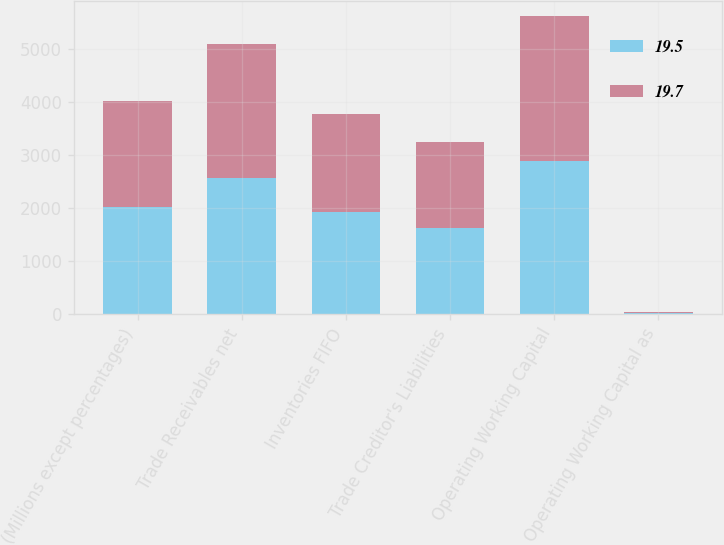<chart> <loc_0><loc_0><loc_500><loc_500><stacked_bar_chart><ecel><fcel>(Millions except percentages)<fcel>Trade Receivables net<fcel>Inventories FIFO<fcel>Trade Creditor's Liabilities<fcel>Operating Working Capital<fcel>Operating Working Capital as<nl><fcel>19.5<fcel>2012<fcel>2568<fcel>1930<fcel>1620<fcel>2878<fcel>19.7<nl><fcel>19.7<fcel>2011<fcel>2512<fcel>1839<fcel>1612<fcel>2739<fcel>19.5<nl></chart> 